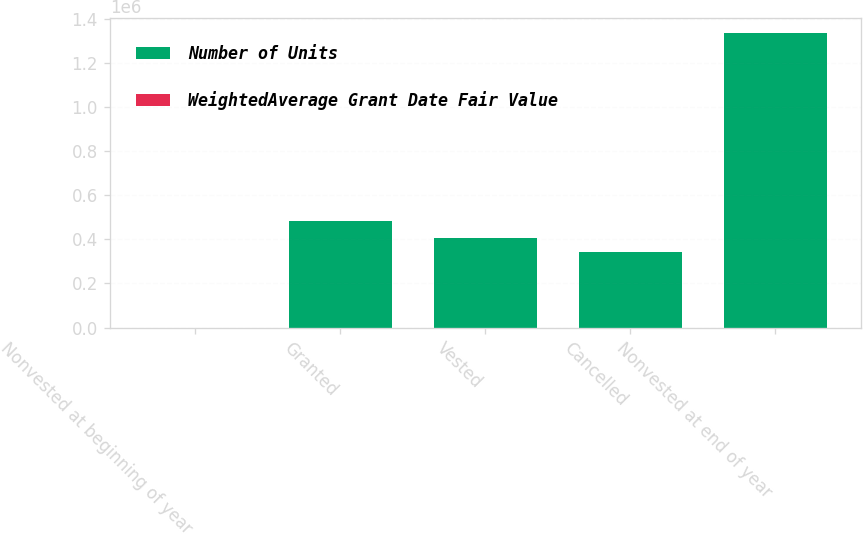Convert chart to OTSL. <chart><loc_0><loc_0><loc_500><loc_500><stacked_bar_chart><ecel><fcel>Nonvested at beginning of year<fcel>Granted<fcel>Vested<fcel>Cancelled<fcel>Nonvested at end of year<nl><fcel>Number of Units<fcel>83.79<fcel>482428<fcel>406844<fcel>344965<fcel>1.33667e+06<nl><fcel>WeightedAverage Grant Date Fair Value<fcel>44.21<fcel>83.79<fcel>83.34<fcel>30.39<fcel>67.56<nl></chart> 